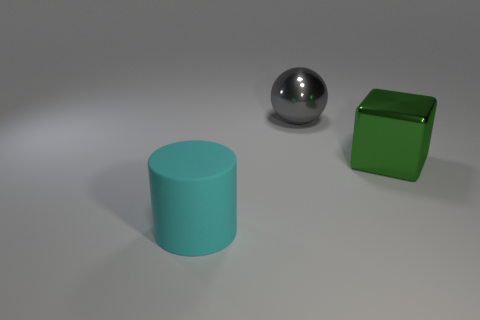Add 3 cyan rubber objects. How many objects exist? 6 Subtract all purple spheres. How many blue cubes are left? 0 Subtract all blue rubber blocks. Subtract all cyan cylinders. How many objects are left? 2 Add 1 large metal blocks. How many large metal blocks are left? 2 Add 2 big brown metal cubes. How many big brown metal cubes exist? 2 Subtract 0 gray cubes. How many objects are left? 3 Subtract all cylinders. How many objects are left? 2 Subtract all red cylinders. Subtract all yellow spheres. How many cylinders are left? 1 